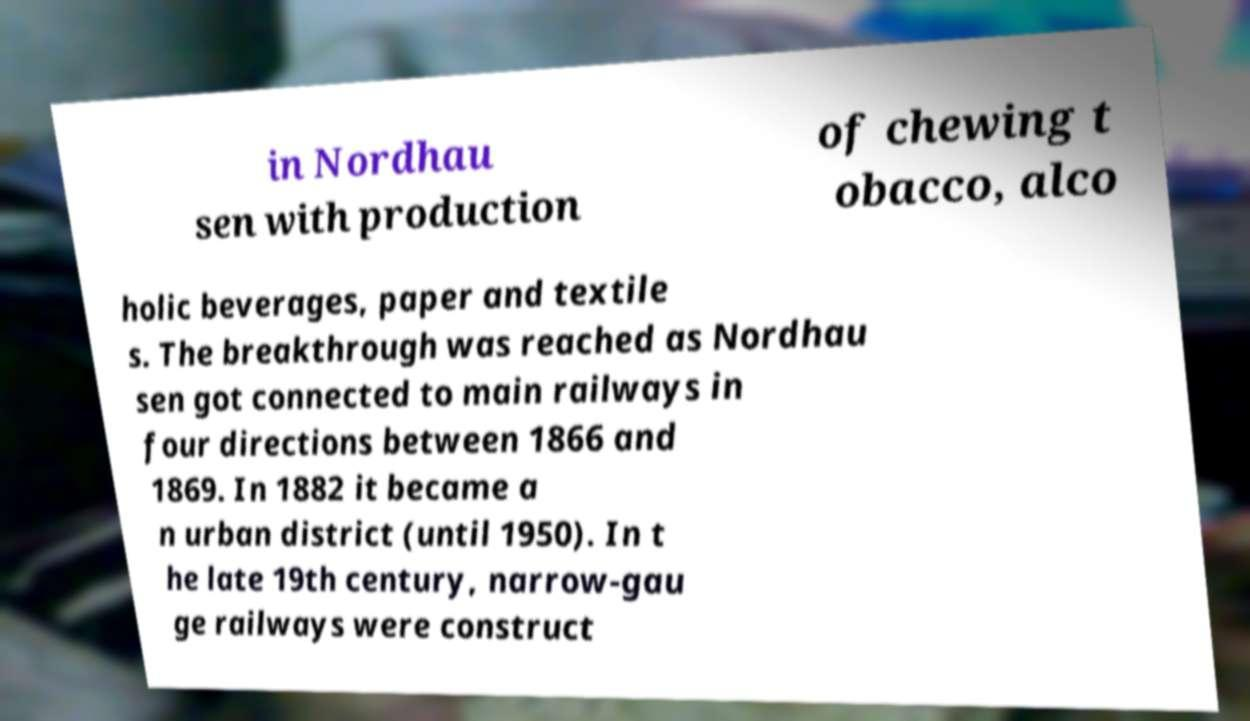Can you read and provide the text displayed in the image?This photo seems to have some interesting text. Can you extract and type it out for me? in Nordhau sen with production of chewing t obacco, alco holic beverages, paper and textile s. The breakthrough was reached as Nordhau sen got connected to main railways in four directions between 1866 and 1869. In 1882 it became a n urban district (until 1950). In t he late 19th century, narrow-gau ge railways were construct 